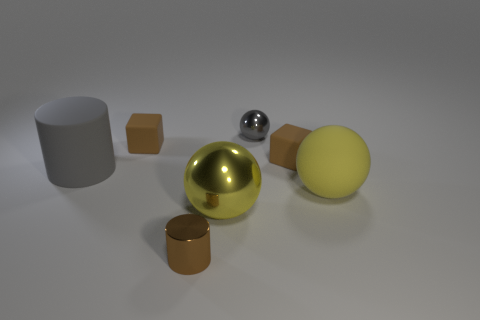Subtract all gray cubes. How many yellow spheres are left? 2 Subtract all big yellow balls. How many balls are left? 1 Add 2 gray things. How many objects exist? 9 Subtract all blocks. How many objects are left? 5 Add 3 tiny metallic objects. How many tiny metallic objects exist? 5 Subtract 0 purple balls. How many objects are left? 7 Subtract all brown cylinders. Subtract all large purple metal cylinders. How many objects are left? 6 Add 4 large cylinders. How many large cylinders are left? 5 